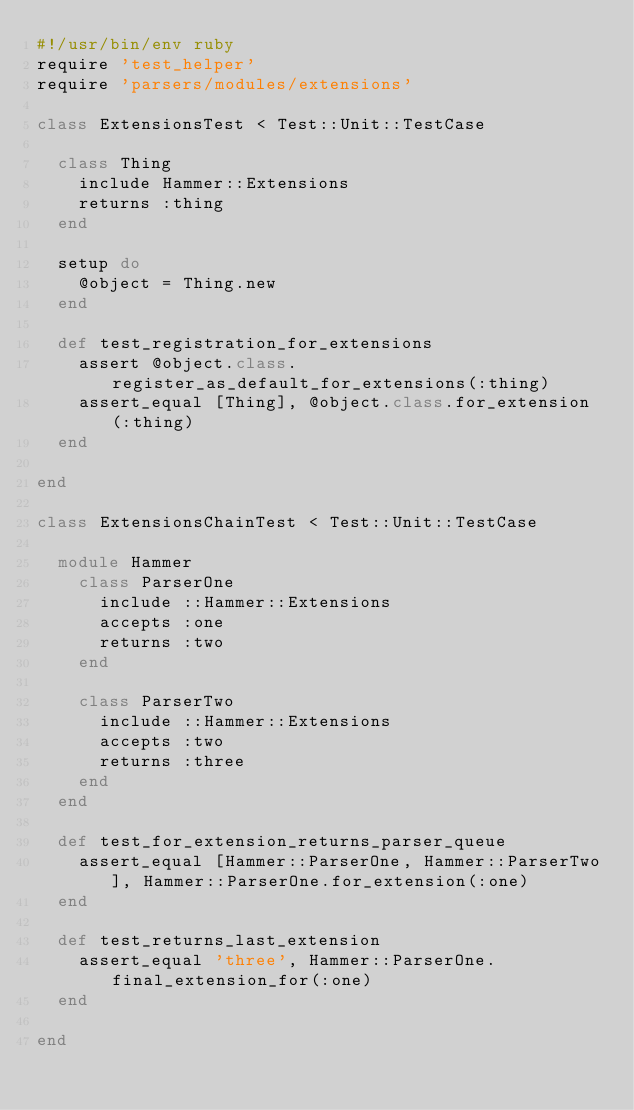<code> <loc_0><loc_0><loc_500><loc_500><_Ruby_>#!/usr/bin/env ruby
require 'test_helper'
require 'parsers/modules/extensions'

class ExtensionsTest < Test::Unit::TestCase

  class Thing
    include Hammer::Extensions
    returns :thing
  end

  setup do
    @object = Thing.new
  end

  def test_registration_for_extensions
    assert @object.class.register_as_default_for_extensions(:thing)
    assert_equal [Thing], @object.class.for_extension(:thing)
  end

end

class ExtensionsChainTest < Test::Unit::TestCase

  module Hammer
    class ParserOne
      include ::Hammer::Extensions
      accepts :one
      returns :two
    end

    class ParserTwo
      include ::Hammer::Extensions
      accepts :two
      returns :three
    end
  end

  def test_for_extension_returns_parser_queue
    assert_equal [Hammer::ParserOne, Hammer::ParserTwo], Hammer::ParserOne.for_extension(:one)
  end

  def test_returns_last_extension
    assert_equal 'three', Hammer::ParserOne.final_extension_for(:one)
  end

end</code> 